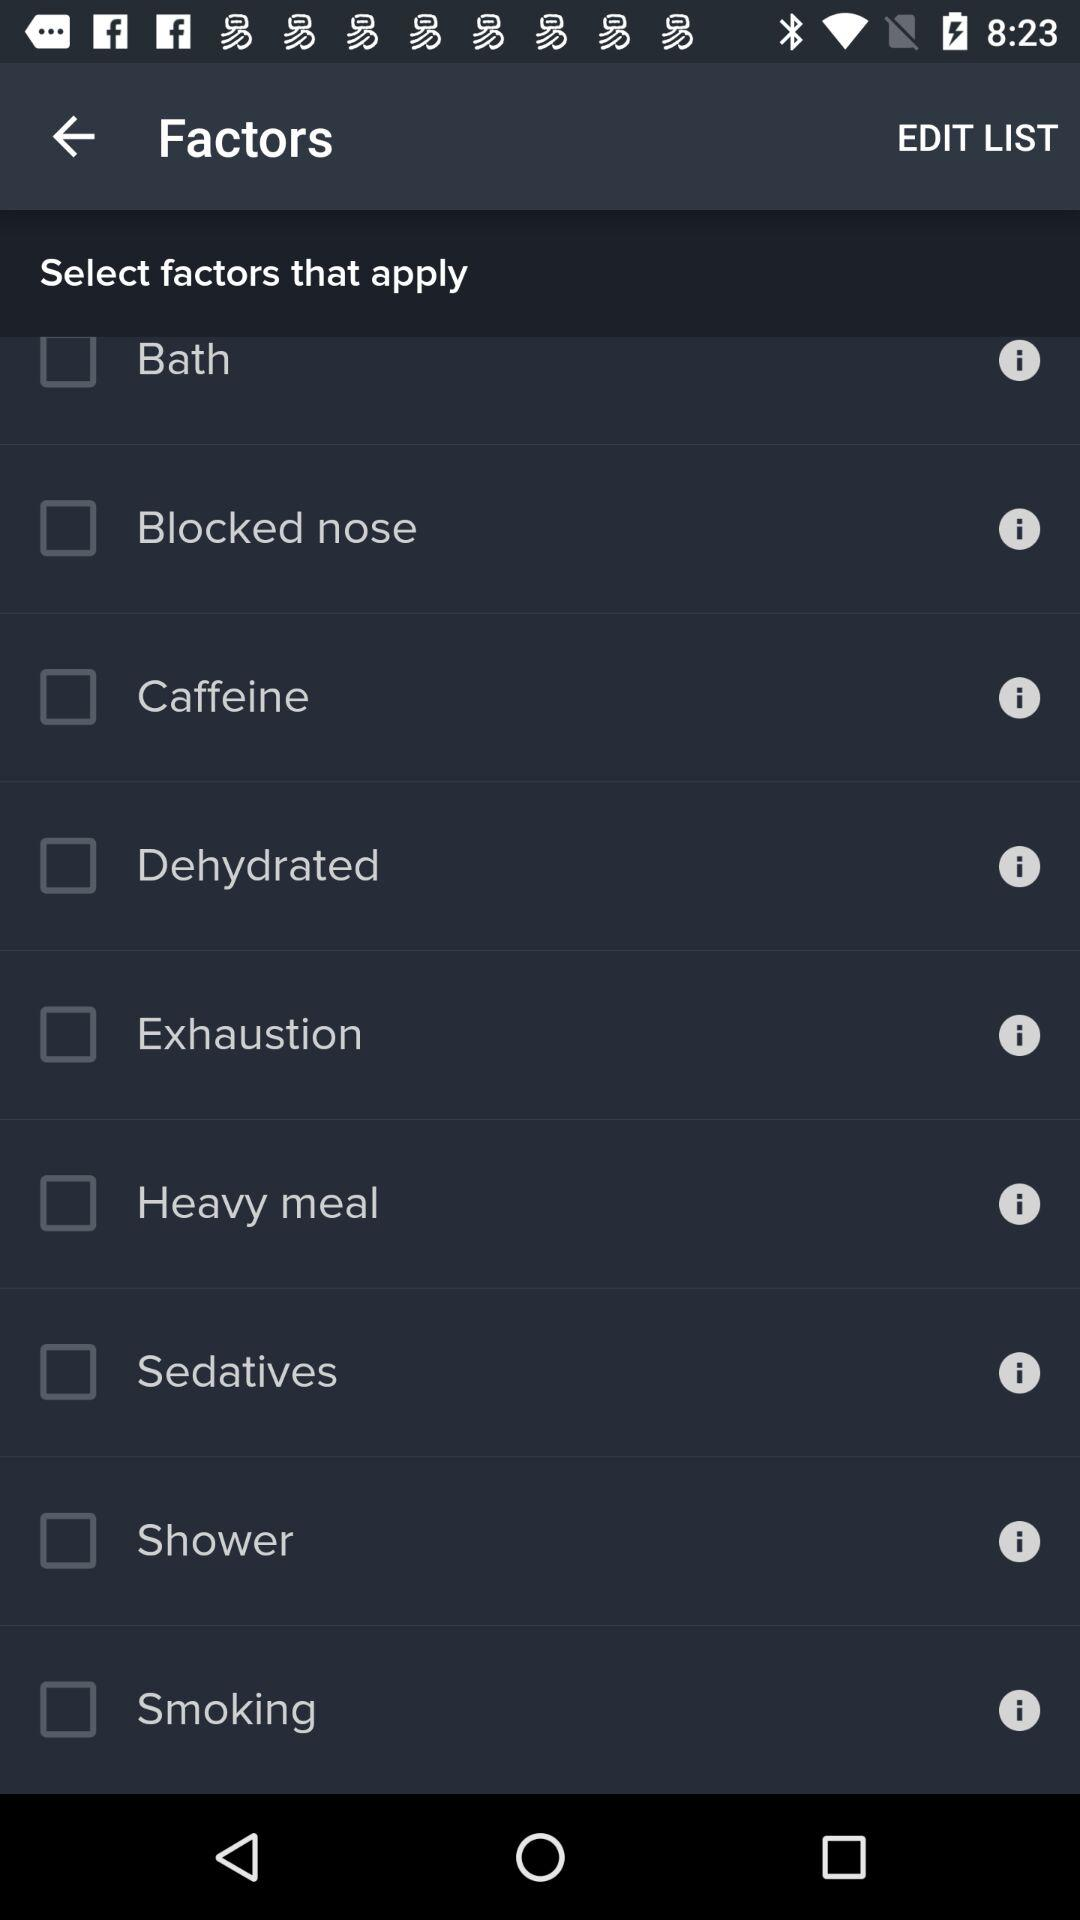What is the status of "Shower"? The status is "off". 